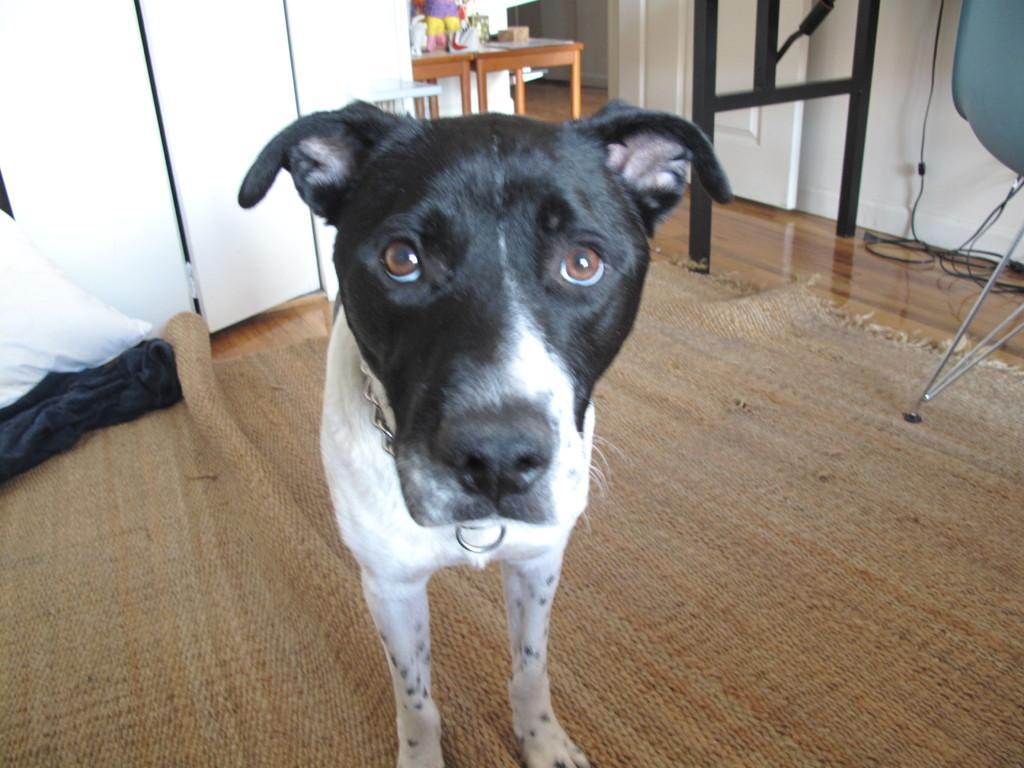Could you give a brief overview of what you see in this image? This image is taken inside a room. At the bottom of the image there is a floor with mat. At the background there is a cupboard, wall and a door. In the middle of the image there is a dog. 